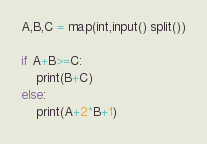Convert code to text. <code><loc_0><loc_0><loc_500><loc_500><_Python_>A,B,C = map(int,input().split())

if A+B>=C:
    print(B+C)
else:
    print(A+2*B+1)</code> 